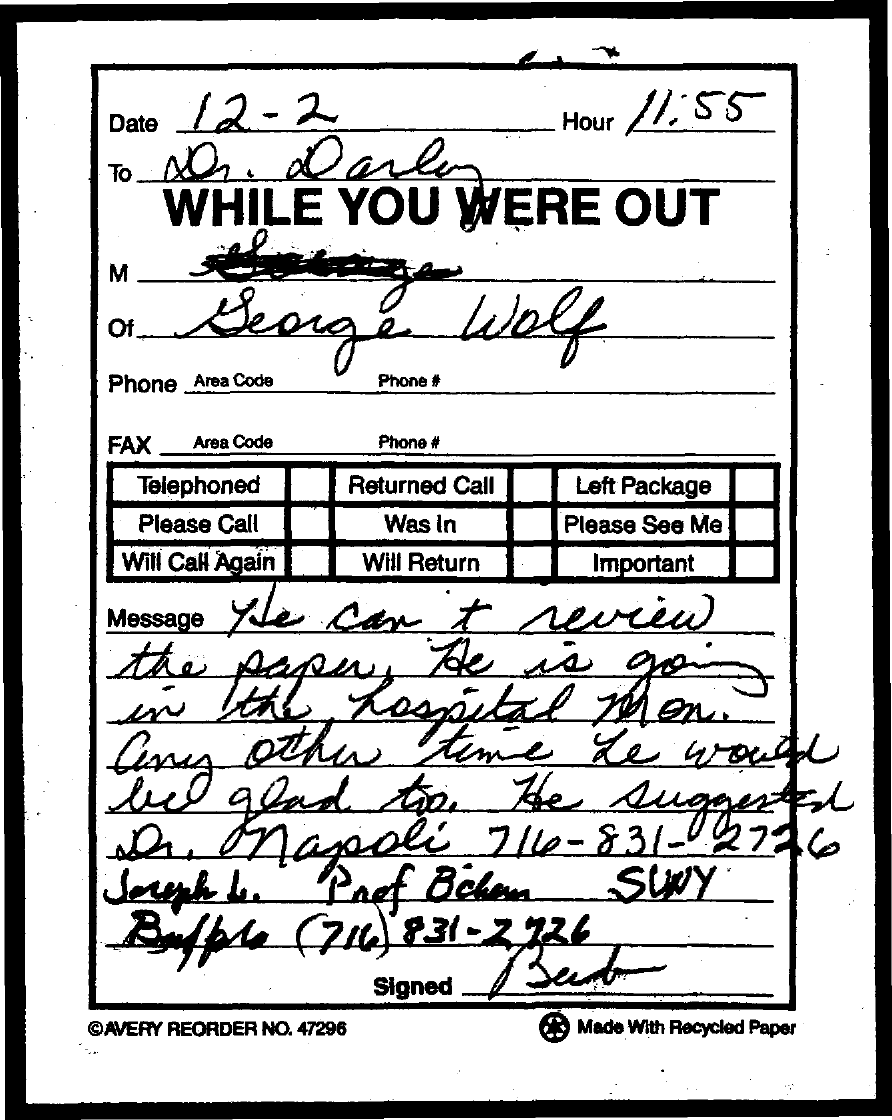Outline some significant characteristics in this image. The hour mentioned in the document is 11:55. 